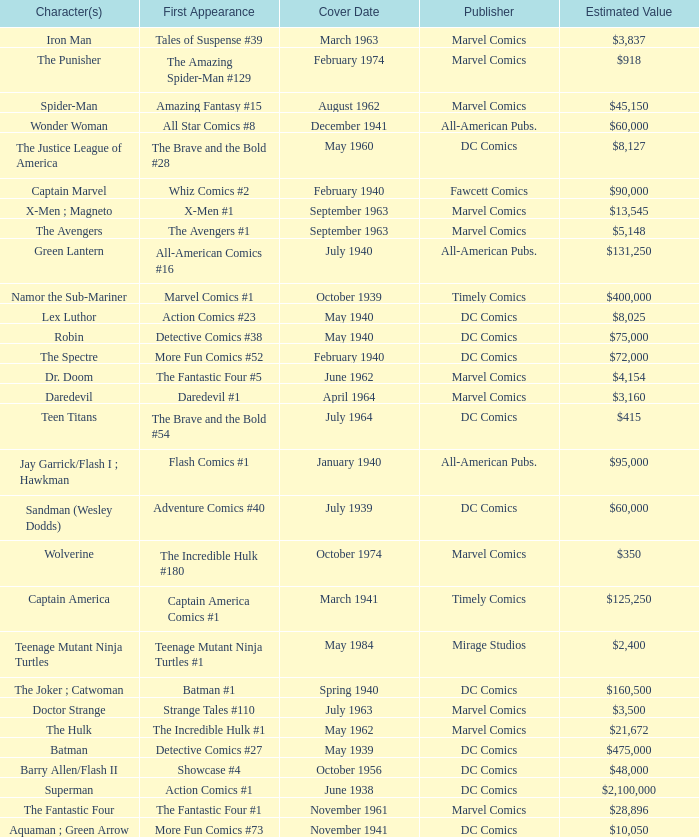What is Action Comics #1's estimated value? $2,100,000. Could you parse the entire table as a dict? {'header': ['Character(s)', 'First Appearance', 'Cover Date', 'Publisher', 'Estimated Value'], 'rows': [['Iron Man', 'Tales of Suspense #39', 'March 1963', 'Marvel Comics', '$3,837'], ['The Punisher', 'The Amazing Spider-Man #129', 'February 1974', 'Marvel Comics', '$918'], ['Spider-Man', 'Amazing Fantasy #15', 'August 1962', 'Marvel Comics', '$45,150'], ['Wonder Woman', 'All Star Comics #8', 'December 1941', 'All-American Pubs.', '$60,000'], ['The Justice League of America', 'The Brave and the Bold #28', 'May 1960', 'DC Comics', '$8,127'], ['Captain Marvel', 'Whiz Comics #2', 'February 1940', 'Fawcett Comics', '$90,000'], ['X-Men ; Magneto', 'X-Men #1', 'September 1963', 'Marvel Comics', '$13,545'], ['The Avengers', 'The Avengers #1', 'September 1963', 'Marvel Comics', '$5,148'], ['Green Lantern', 'All-American Comics #16', 'July 1940', 'All-American Pubs.', '$131,250'], ['Namor the Sub-Mariner', 'Marvel Comics #1', 'October 1939', 'Timely Comics', '$400,000'], ['Lex Luthor', 'Action Comics #23', 'May 1940', 'DC Comics', '$8,025'], ['Robin', 'Detective Comics #38', 'May 1940', 'DC Comics', '$75,000'], ['The Spectre', 'More Fun Comics #52', 'February 1940', 'DC Comics', '$72,000'], ['Dr. Doom', 'The Fantastic Four #5', 'June 1962', 'Marvel Comics', '$4,154'], ['Daredevil', 'Daredevil #1', 'April 1964', 'Marvel Comics', '$3,160'], ['Teen Titans', 'The Brave and the Bold #54', 'July 1964', 'DC Comics', '$415'], ['Jay Garrick/Flash I ; Hawkman', 'Flash Comics #1', 'January 1940', 'All-American Pubs.', '$95,000'], ['Sandman (Wesley Dodds)', 'Adventure Comics #40', 'July 1939', 'DC Comics', '$60,000'], ['Wolverine', 'The Incredible Hulk #180', 'October 1974', 'Marvel Comics', '$350'], ['Captain America', 'Captain America Comics #1', 'March 1941', 'Timely Comics', '$125,250'], ['Teenage Mutant Ninja Turtles', 'Teenage Mutant Ninja Turtles #1', 'May 1984', 'Mirage Studios', '$2,400'], ['The Joker ; Catwoman', 'Batman #1', 'Spring 1940', 'DC Comics', '$160,500'], ['Doctor Strange', 'Strange Tales #110', 'July 1963', 'Marvel Comics', '$3,500'], ['The Hulk', 'The Incredible Hulk #1', 'May 1962', 'Marvel Comics', '$21,672'], ['Batman', 'Detective Comics #27', 'May 1939', 'DC Comics', '$475,000'], ['Barry Allen/Flash II', 'Showcase #4', 'October 1956', 'DC Comics', '$48,000'], ['Superman', 'Action Comics #1', 'June 1938', 'DC Comics', '$2,100,000'], ['The Fantastic Four', 'The Fantastic Four #1', 'November 1961', 'Marvel Comics', '$28,896'], ['Aquaman ; Green Arrow', 'More Fun Comics #73', 'November 1941', 'DC Comics', '$10,050']]} 